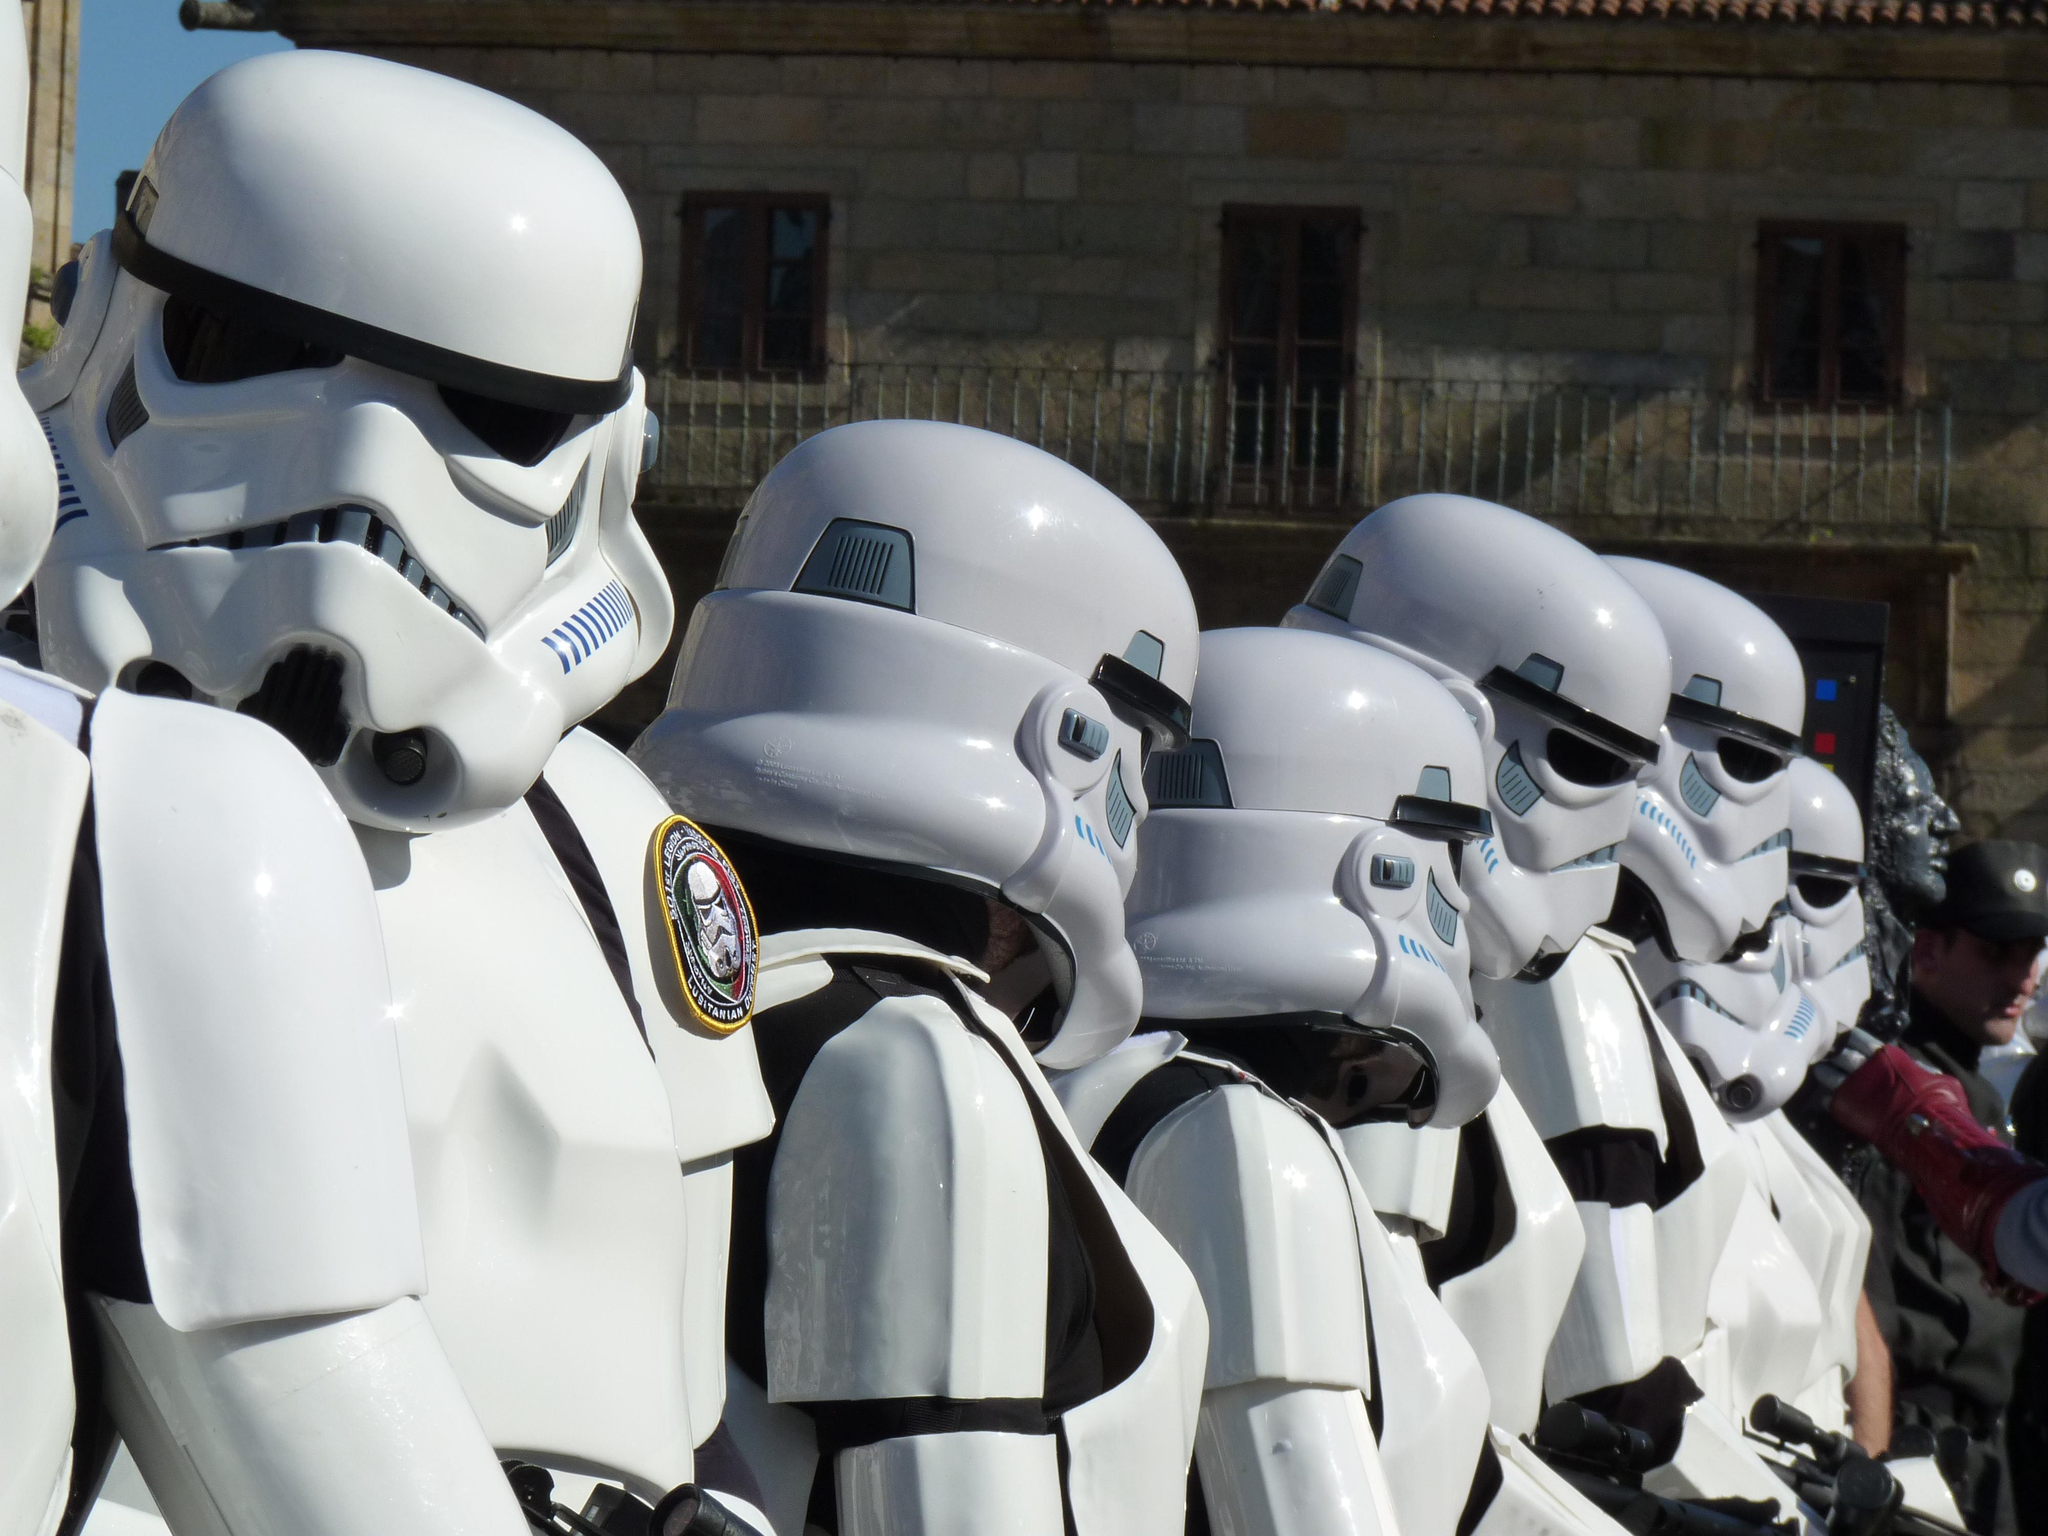What can be found at the bottom of the image? There are statues at the bottom of the image. What type of structure is visible in the background of the image? There is a building in the background of the image. What reason does the crook have for being in the alley in the image? There is no crook or alley present in the image; it only features statues at the bottom and a building in the background. 